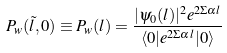<formula> <loc_0><loc_0><loc_500><loc_500>P _ { w } ( \tilde { l } , 0 ) \equiv P _ { w } ( l ) = \frac { | \psi _ { 0 } ( l ) | ^ { 2 } e ^ { 2 \Sigma \alpha l } } { \langle 0 | e ^ { 2 \Sigma \alpha l } | 0 \rangle }</formula> 